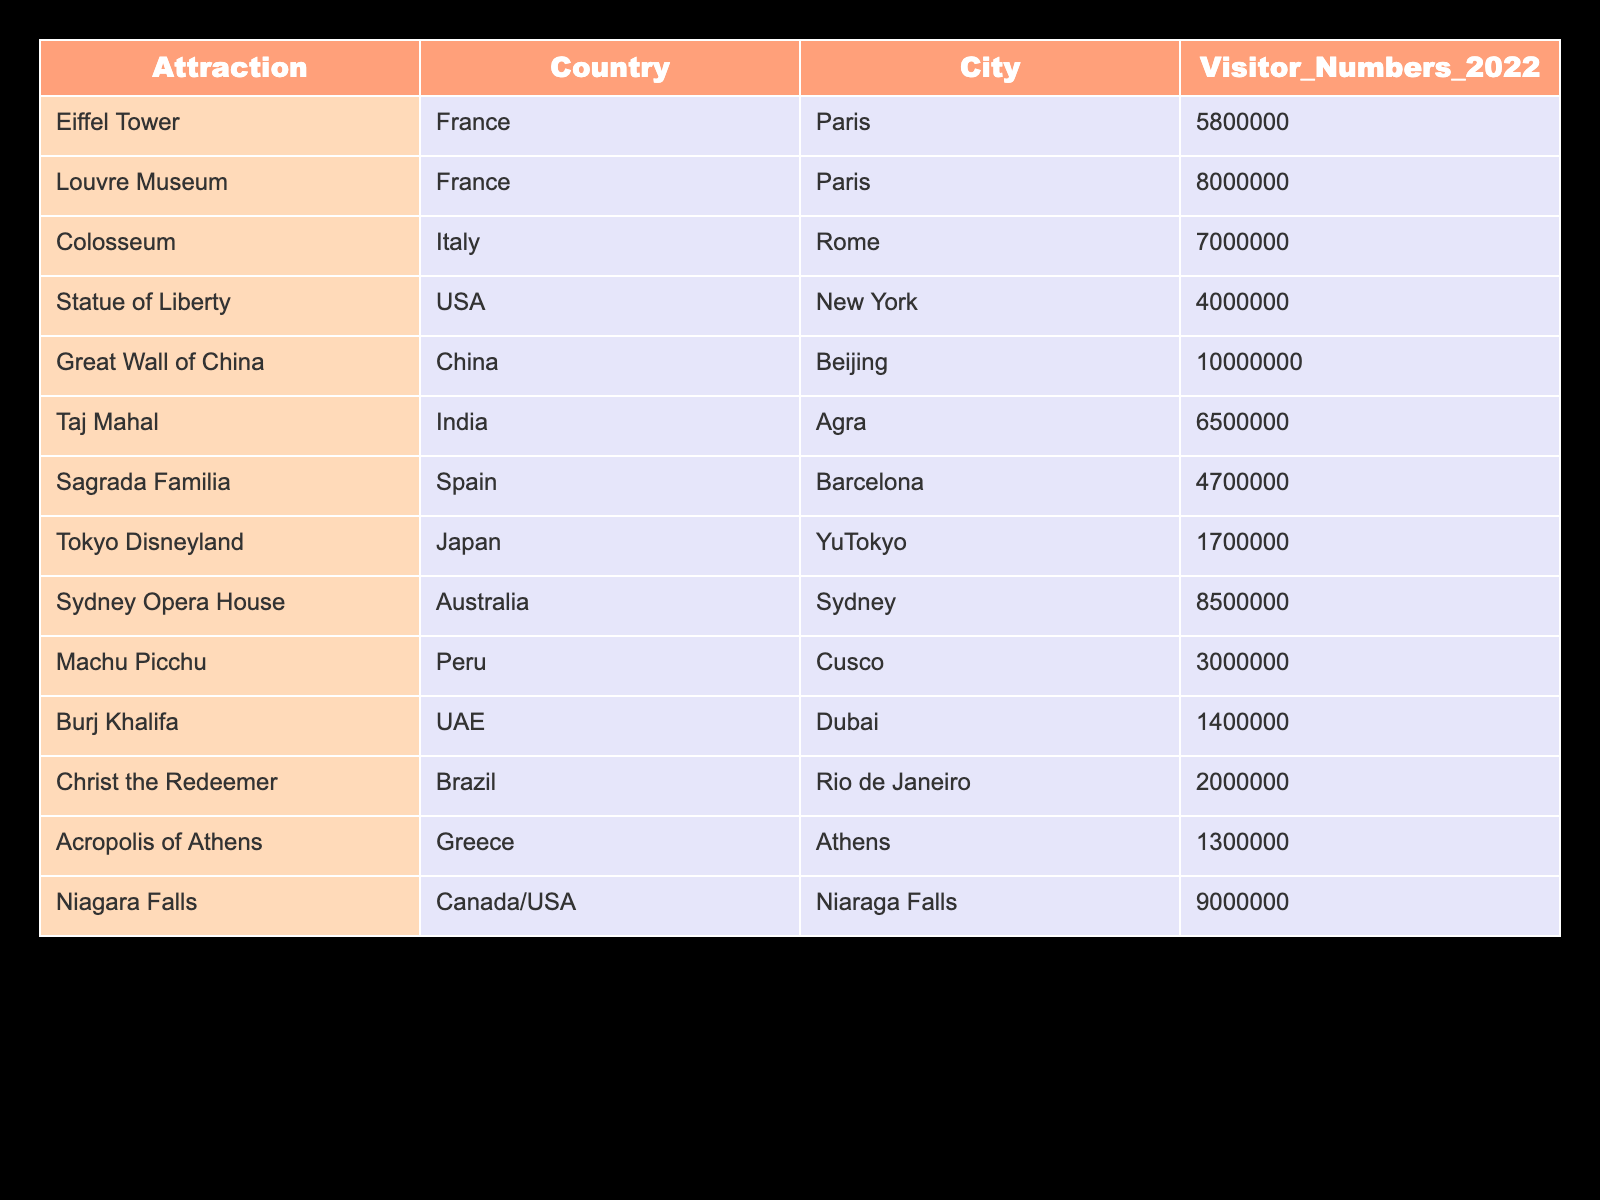What is the visitor number for the Louvre Museum? The data shows that the Louvre Museum is listed with a visitor number of 8,000,000 in 2022.
Answer: 8,000,000 Which attraction had the highest number of visitors in 2022? The table indicates that the Great Wall of China had the highest number of visitors, with 10,000,000 in 2022.
Answer: Great Wall of China How many more visitors did the Eiffel Tower have compared to the Burj Khalifa? The Eiffel Tower had 5,800,000 visitors and the Burj Khalifa had 1,400,000 visitors. The difference is 5,800,000 - 1,400,000 = 4,400,000.
Answer: 4,400,000 Is the Statue of Liberty among the top five attractions by visitor numbers? By comparing the visitor numbers, the Statue of Liberty had 4,000,000 visitors, which is less than the fifth highest number (Niagara Falls with 9,000,000). Therefore, it is not in the top five.
Answer: No What is the average number of visitors for the attractions in France? The attractions in France are the Eiffel Tower (5,800,000) and the Louvre Museum (8,000,000). We sum these numbers: 5,800,000 + 8,000,000 = 13,800,000. The average is 13,800,000 / 2 = 6,900,000.
Answer: 6,900,000 How many attractions had visitor numbers over 6,000,000? The attractions with visitor numbers above 6,000,000 are the Great Wall of China (10,000,000), Louvre Museum (8,000,000), Sydney Opera House (8,500,000), and Niagara Falls (9,000,000). This means there are four attractions.
Answer: 4 Which country had the attraction with the least visitors? The attraction with the least visitors is the Tokyo Disneyland with 1,700,000, which is located in Japan.
Answer: Japan How many visitors in total did all attractions receive? Summing up all listed visitor numbers: 5,800,000 + 8,000,000 + 7,000,000 + 4,000,000 + 10,000,000 + 6,500,000 + 4,700,000 + 1,700,000 + 8,500,000 + 3,000,000 + 1,400,000 + 2,000,000 + 1,300,000 + 9,000,000 = 74,600,000.
Answer: 74,600,000 